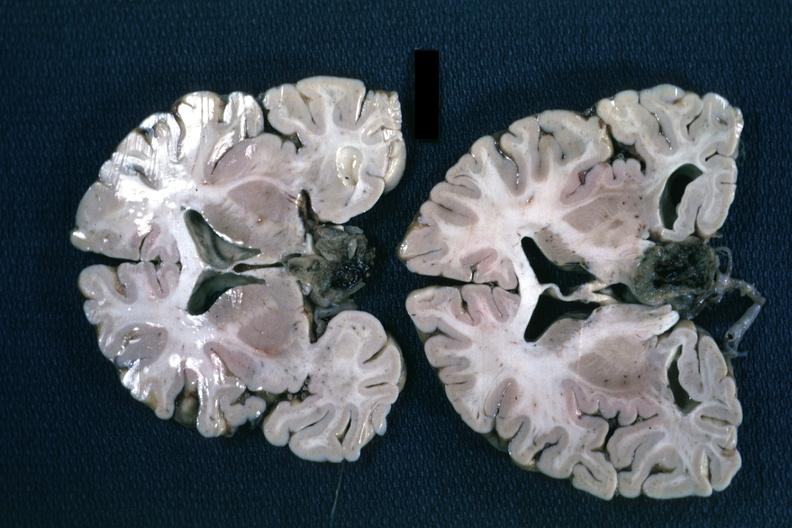where does this belong to?
Answer the question using a single word or phrase. Endocrine system 